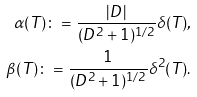Convert formula to latex. <formula><loc_0><loc_0><loc_500><loc_500>\alpha ( T ) \colon = \frac { | D | } { ( D ^ { 2 } + 1 ) ^ { 1 / 2 } } \delta ( T ) , \\ \beta ( T ) \colon = \frac { 1 } { ( D ^ { 2 } + 1 ) ^ { 1 / 2 } } \delta ^ { 2 } ( T ) .</formula> 